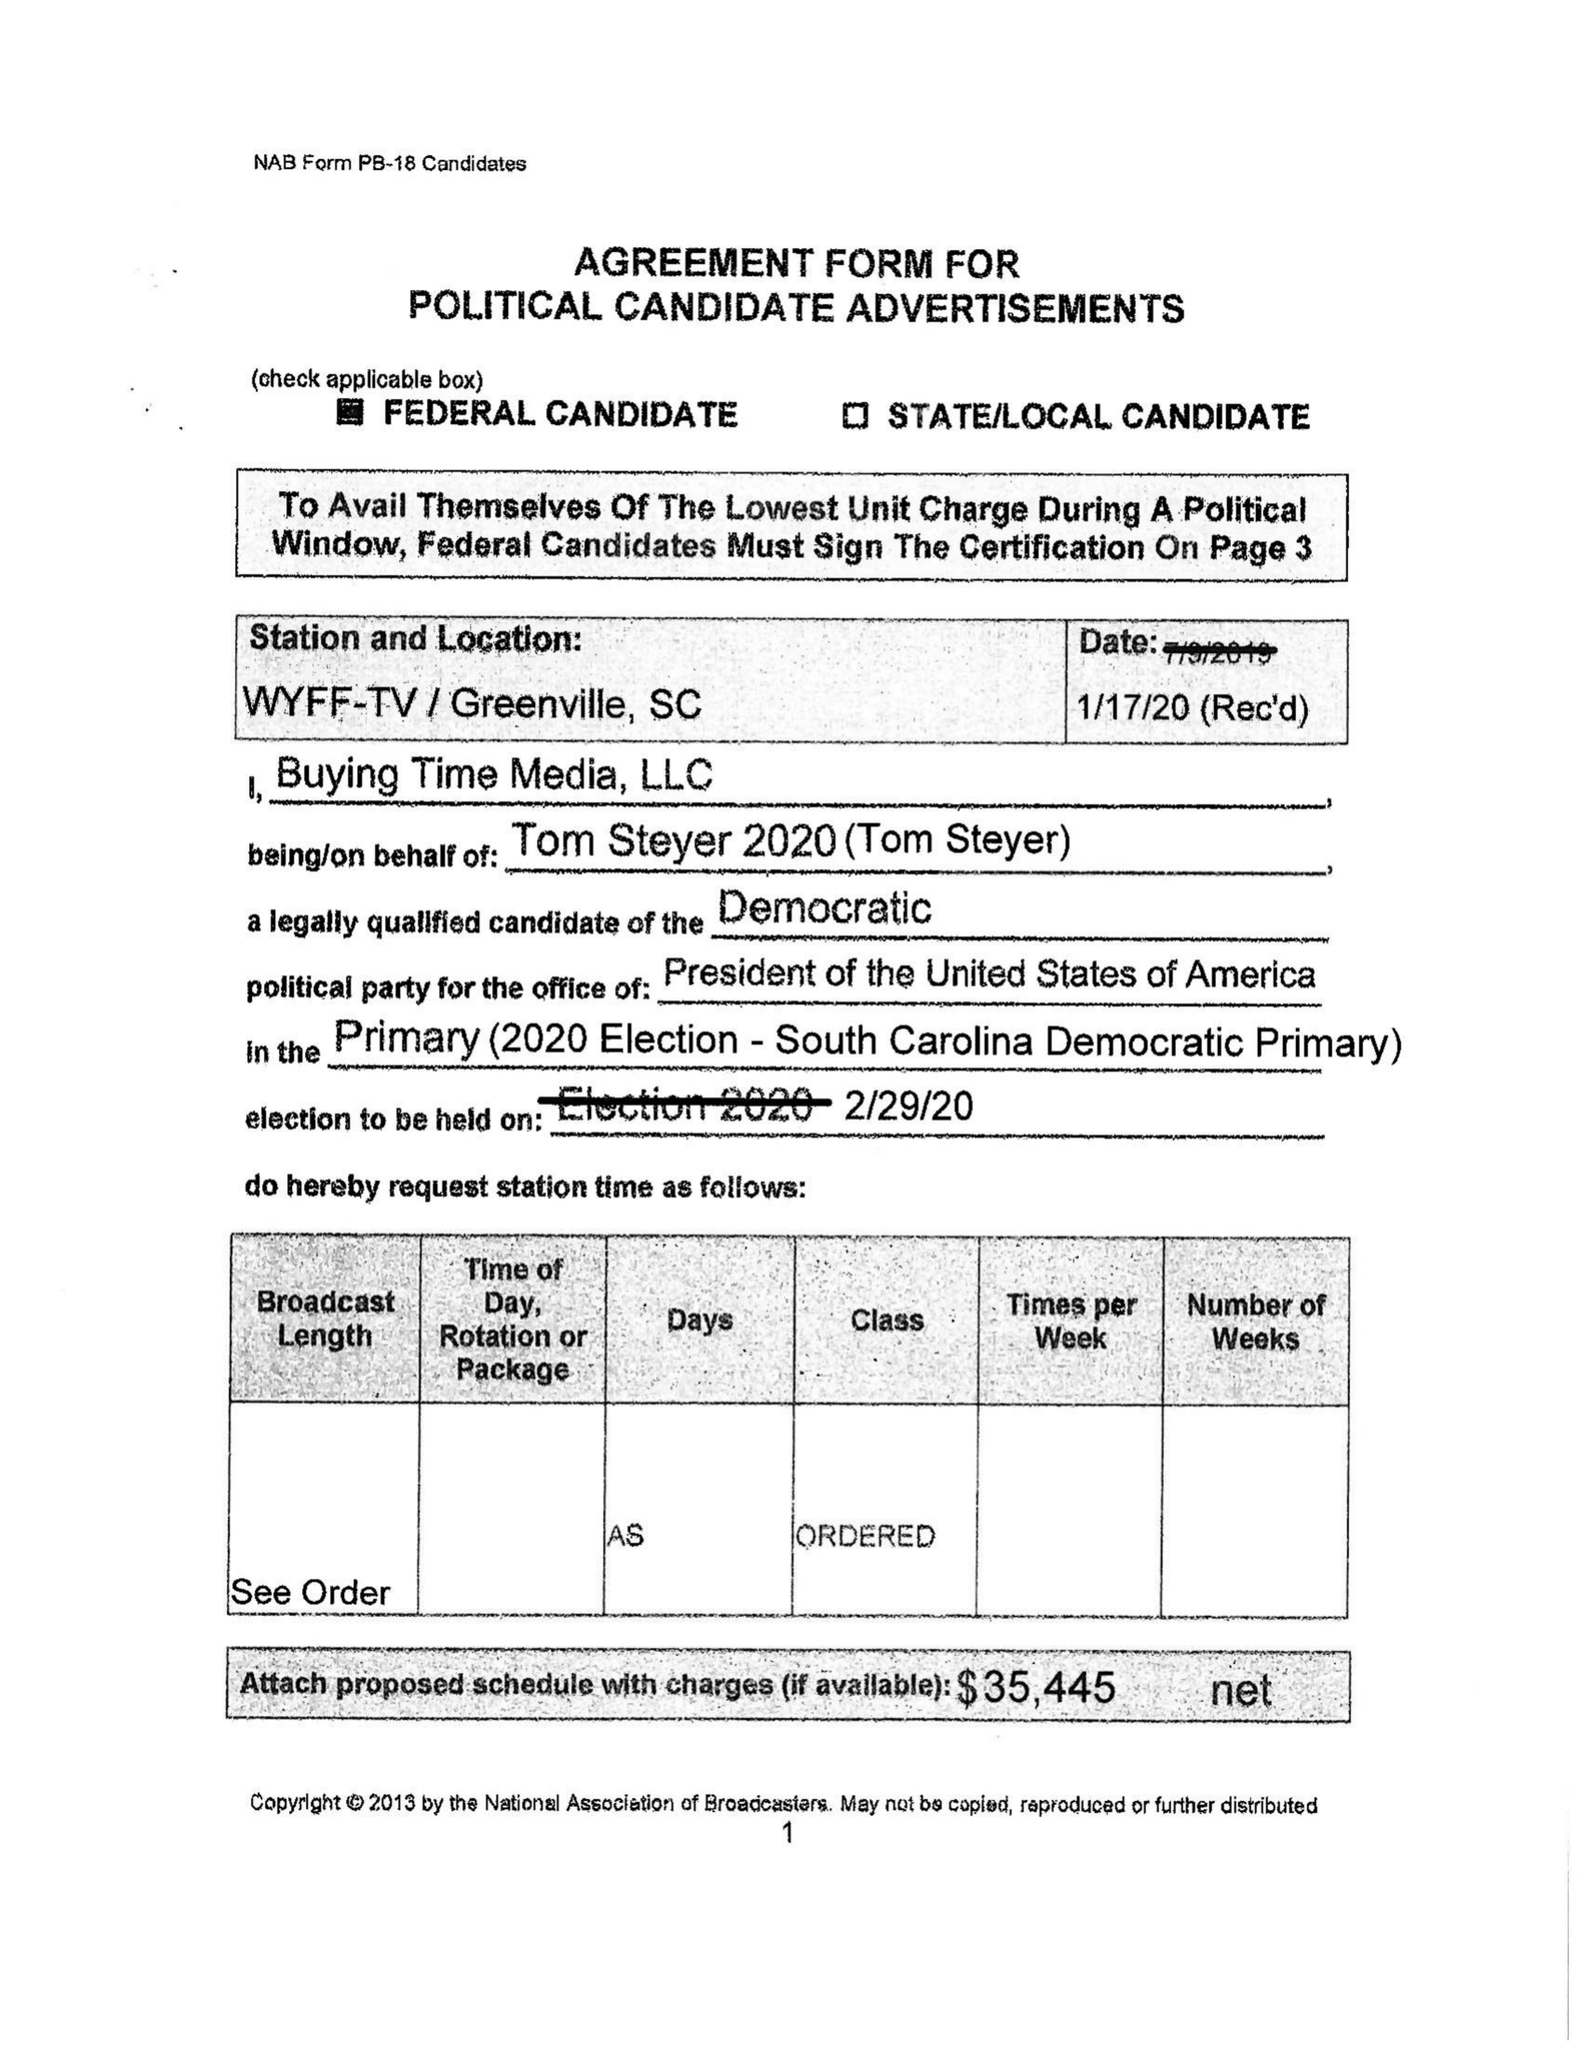What is the value for the advertiser?
Answer the question using a single word or phrase. TOM STEYER 2020 (TOMSTEYER) 